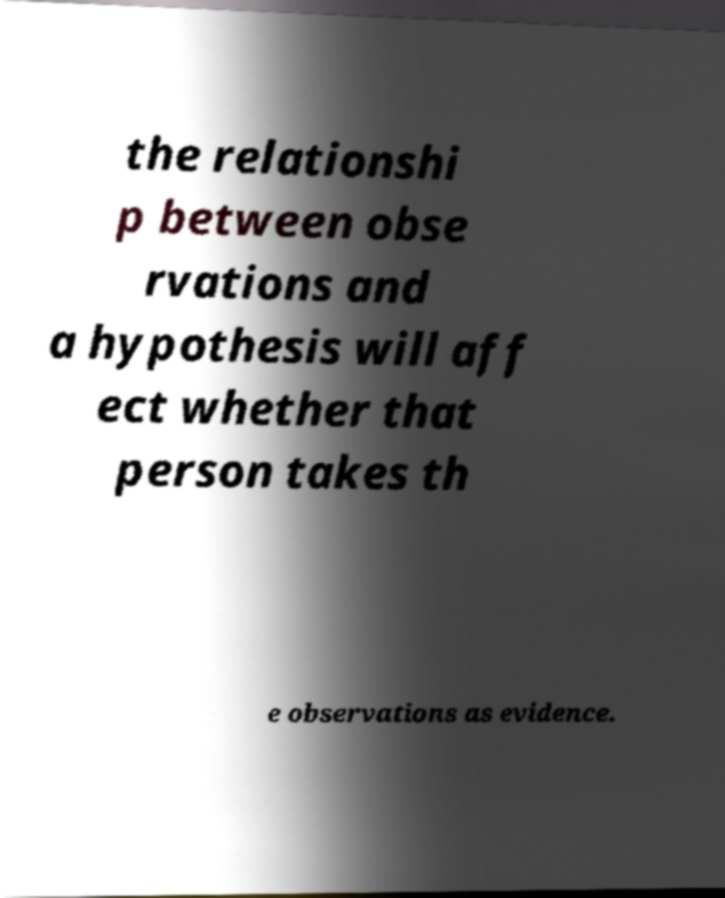I need the written content from this picture converted into text. Can you do that? the relationshi p between obse rvations and a hypothesis will aff ect whether that person takes th e observations as evidence. 